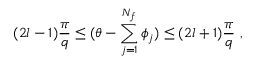<formula> <loc_0><loc_0><loc_500><loc_500>{ ( 2 l - 1 ) \frac { \pi } { q } \leq ( \theta - \sum _ { j = 1 } ^ { N _ { f } } \phi _ { j } ) \leq ( 2 l + 1 ) \frac { \pi } { q } } \, ,</formula> 